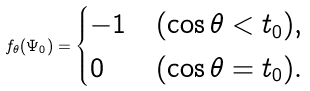<formula> <loc_0><loc_0><loc_500><loc_500>f _ { \theta } ( \Psi _ { 0 } ) = \begin{cases} - 1 & ( \cos \theta < t _ { 0 } ) , \\ 0 & ( \cos \theta = t _ { 0 } ) . \end{cases}</formula> 